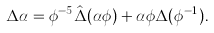Convert formula to latex. <formula><loc_0><loc_0><loc_500><loc_500>\Delta \alpha = \phi ^ { - 5 } \hat { \Delta } ( \alpha \phi ) + \alpha \phi \Delta ( \phi ^ { - 1 } ) .</formula> 